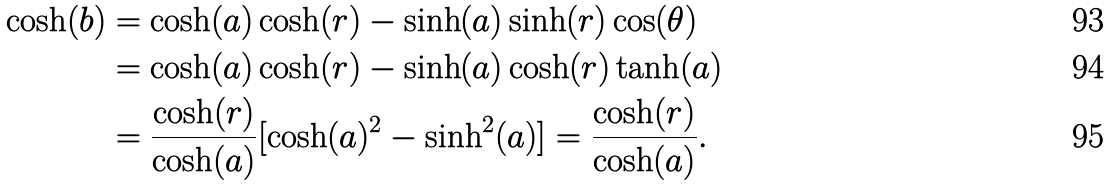Convert formula to latex. <formula><loc_0><loc_0><loc_500><loc_500>\cosh ( b ) & = \cosh ( a ) \cosh ( r ) - \sinh ( a ) \sinh ( r ) \cos ( \theta ) \\ & = \cosh ( a ) \cosh ( r ) - \sinh ( a ) \cosh ( r ) \tanh ( a ) \\ & = \frac { \cosh ( r ) } { \cosh ( a ) } [ \cosh ( a ) ^ { 2 } - \sinh ^ { 2 } ( a ) ] = \frac { \cosh ( r ) } { \cosh ( a ) } .</formula> 